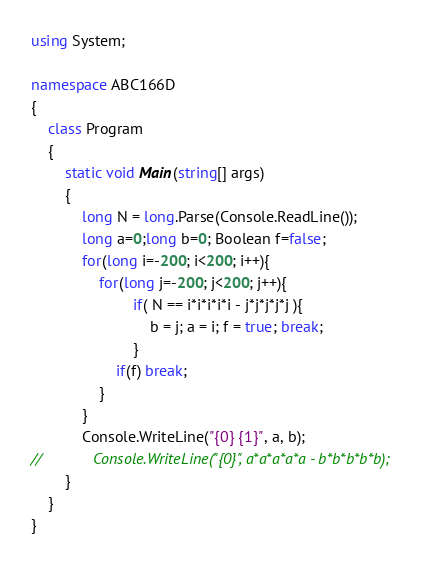<code> <loc_0><loc_0><loc_500><loc_500><_C#_>using System;

namespace ABC166D
{
    class Program
    {
        static void Main(string[] args)
        {
            long N = long.Parse(Console.ReadLine());
            long a=0;long b=0; Boolean f=false;
            for(long i=-200; i<200; i++){
                for(long j=-200; j<200; j++){
                        if( N == i*i*i*i*i - j*j*j*j*j ){
                            b = j; a = i; f = true; break;
                        }
                    if(f) break;                    
                }               
            }
            Console.WriteLine("{0} {1}", a, b);
//            Console.WriteLine("{0}", a*a*a*a*a - b*b*b*b*b);
        }
    }
}
</code> 